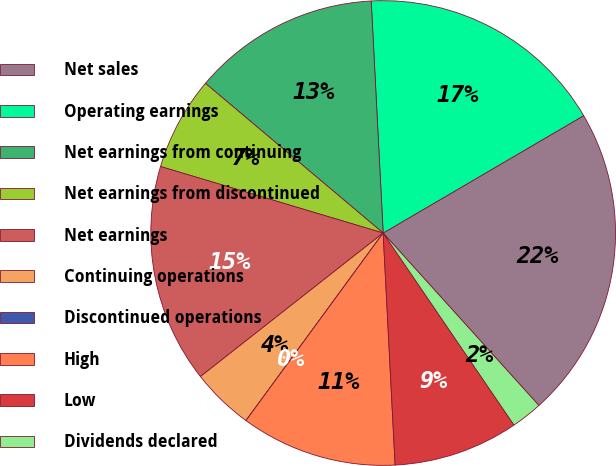Convert chart. <chart><loc_0><loc_0><loc_500><loc_500><pie_chart><fcel>Net sales<fcel>Operating earnings<fcel>Net earnings from continuing<fcel>Net earnings from discontinued<fcel>Net earnings<fcel>Continuing operations<fcel>Discontinued operations<fcel>High<fcel>Low<fcel>Dividends declared<nl><fcel>21.74%<fcel>17.39%<fcel>13.04%<fcel>6.52%<fcel>15.22%<fcel>4.35%<fcel>0.0%<fcel>10.87%<fcel>8.7%<fcel>2.17%<nl></chart> 